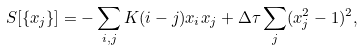<formula> <loc_0><loc_0><loc_500><loc_500>S [ \{ x _ { j } \} ] = - \sum _ { i , j } K ( i - j ) x _ { i } x _ { j } + \Delta \tau \sum _ { j } ( x _ { j } ^ { 2 } - 1 ) ^ { 2 } ,</formula> 